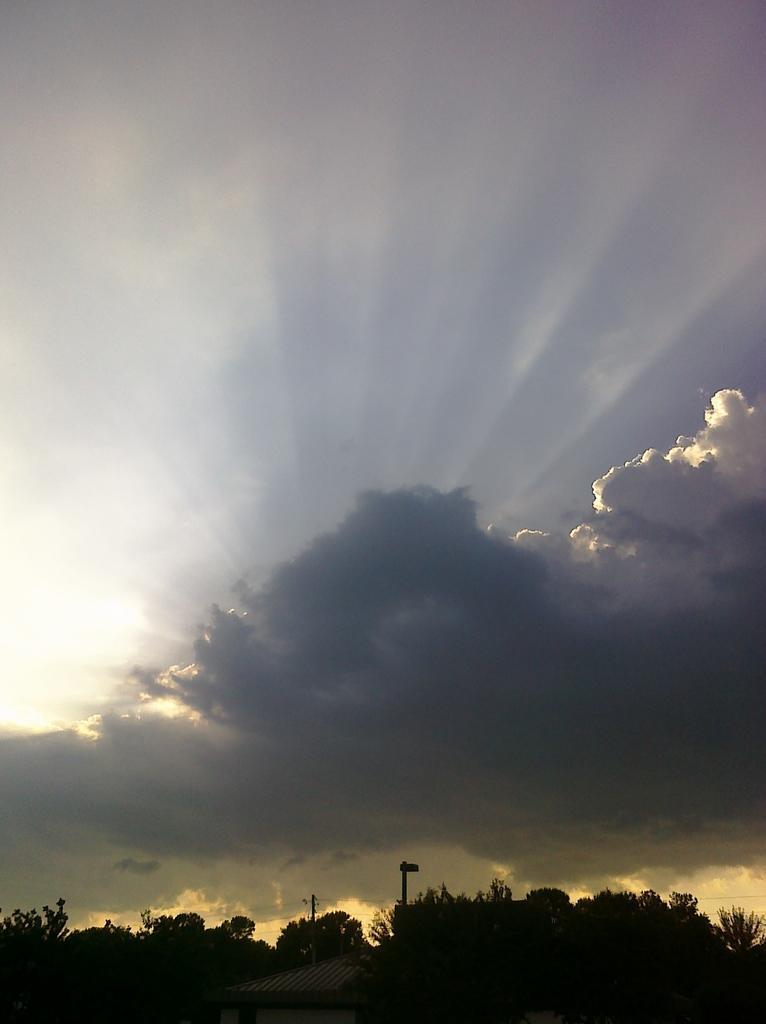Please provide a concise description of this image. This is an outside view. At the bottom of the image I can see a house and trees. On the top of the image I can see the sky and clouds. 